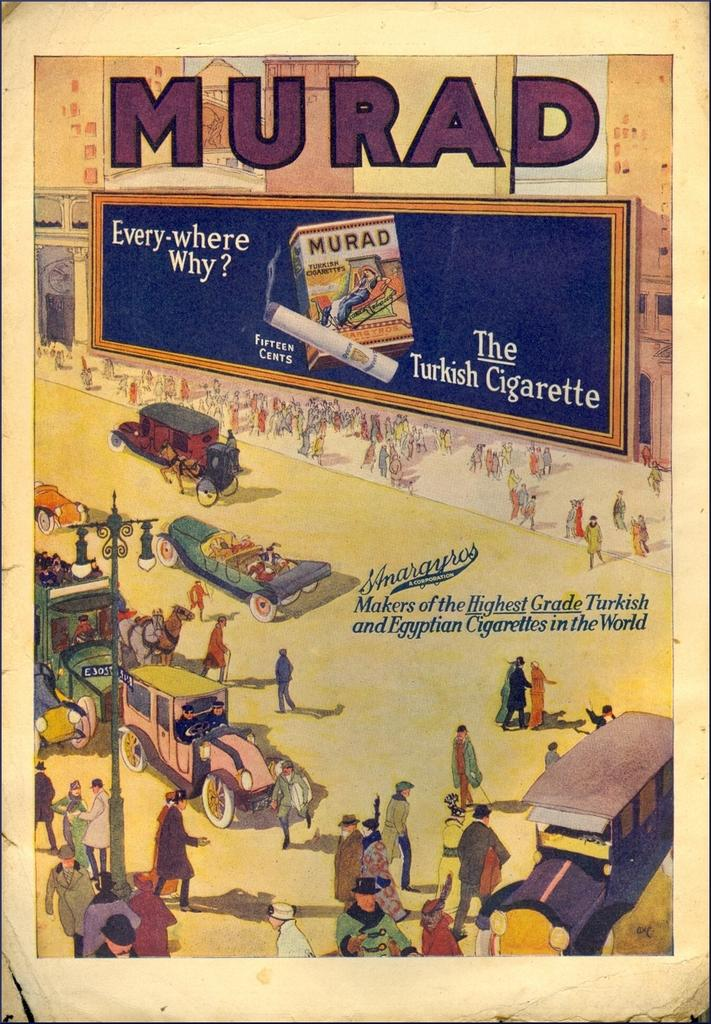<image>
Create a compact narrative representing the image presented. a colorful old time ad for MURAD cigarettes depicting a street scene 